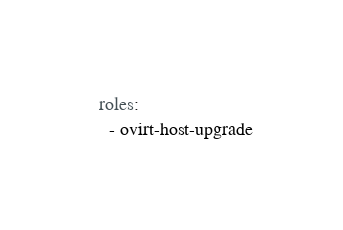Convert code to text. <code><loc_0><loc_0><loc_500><loc_500><_YAML_>  roles:
    - ovirt-host-upgrade
</code> 